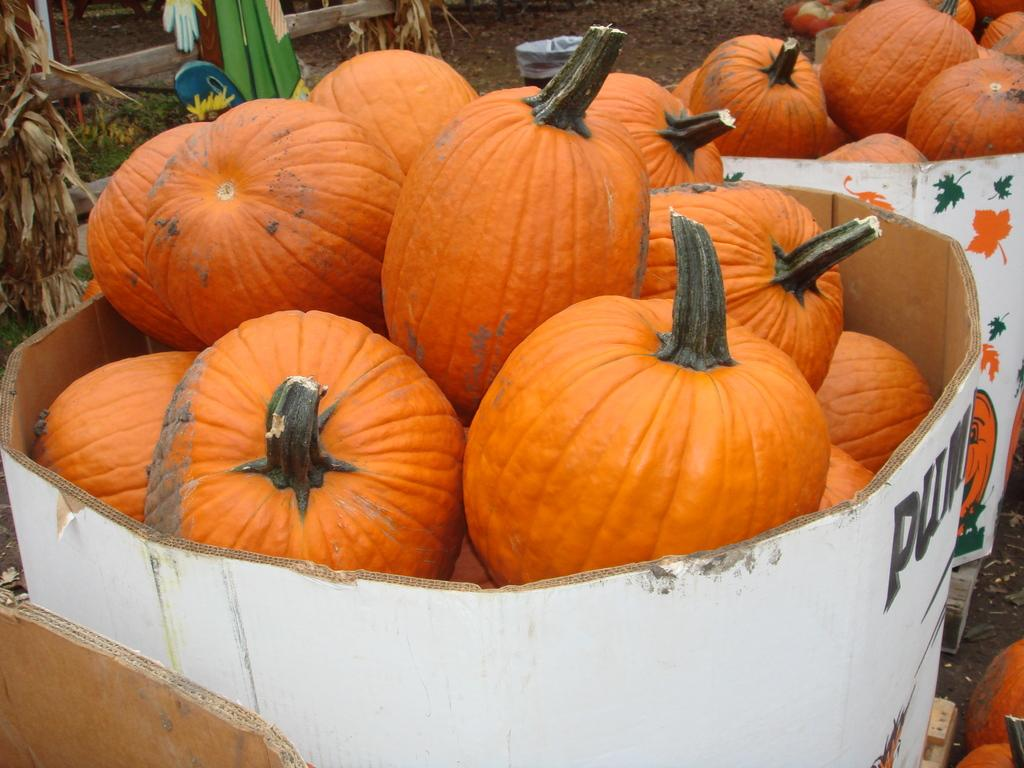How many pumpkin baskets can be seen in the image? There are two pumpkin baskets in the image. Where are the pumpkin baskets located? The pumpkin baskets are on the land. What can be seen in the background of the image? There is a dried tree visible in the background of the image. What type of pin is holding the pumpkin baskets together in the image? There is no pin visible in the image; the pumpkin baskets are not connected to each other. 